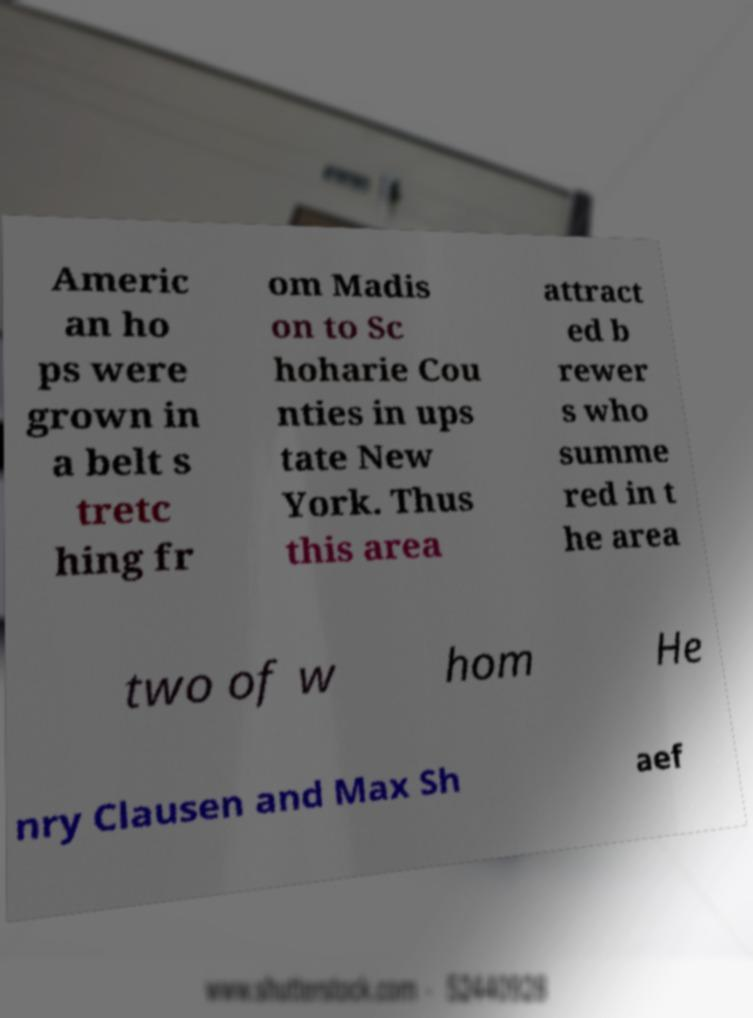Could you extract and type out the text from this image? Americ an ho ps were grown in a belt s tretc hing fr om Madis on to Sc hoharie Cou nties in ups tate New York. Thus this area attract ed b rewer s who summe red in t he area two of w hom He nry Clausen and Max Sh aef 